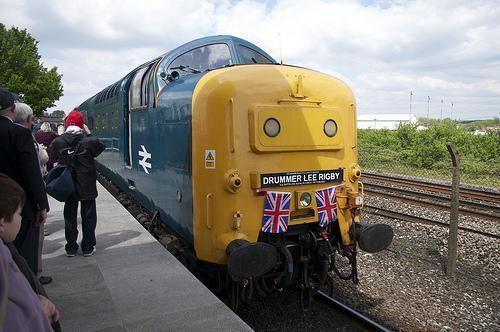How many people are wearing red hats?
Give a very brief answer. 1. How many flags can be seen?
Give a very brief answer. 2. 